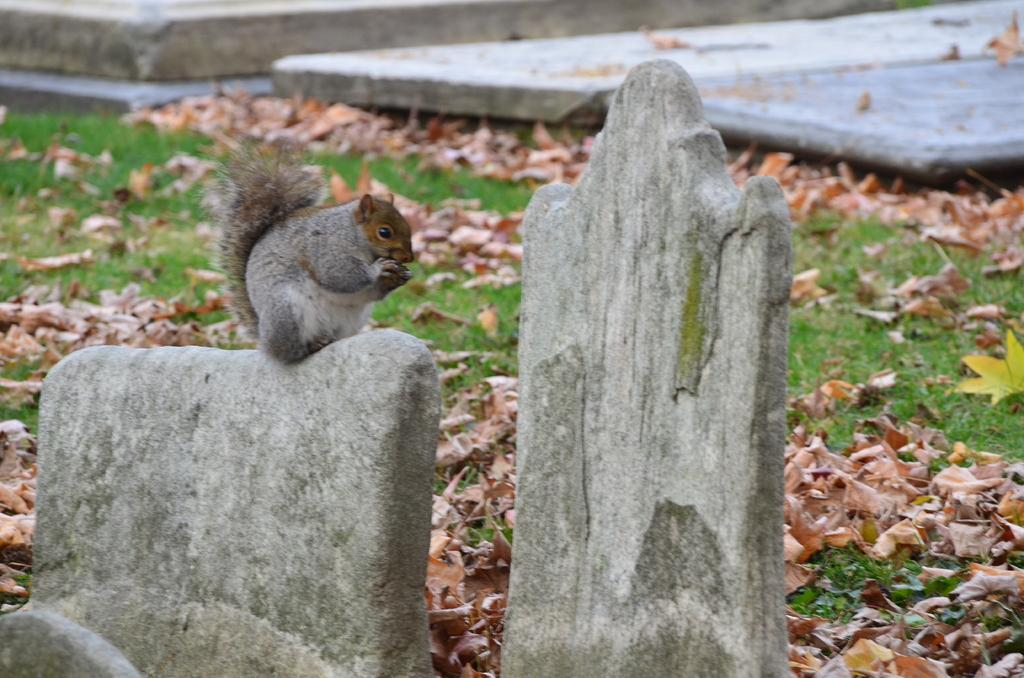What type of animal is in the image? There is a fox squirrel in the image. Where is the fox squirrel located? The fox squirrel is on a concrete structure. What can be seen in the background of the image? There are dried leaves on the grass in the background. What feature is visible that might indicate a path or walkway? There is a path visible in the image. What is the texture of the fox squirrel's brain in the image? There is no information about the texture of the fox squirrel's brain in the image, as the focus is on the animal's appearance and location. 